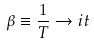<formula> <loc_0><loc_0><loc_500><loc_500>\beta \equiv \frac { 1 } { T } \rightarrow i t</formula> 